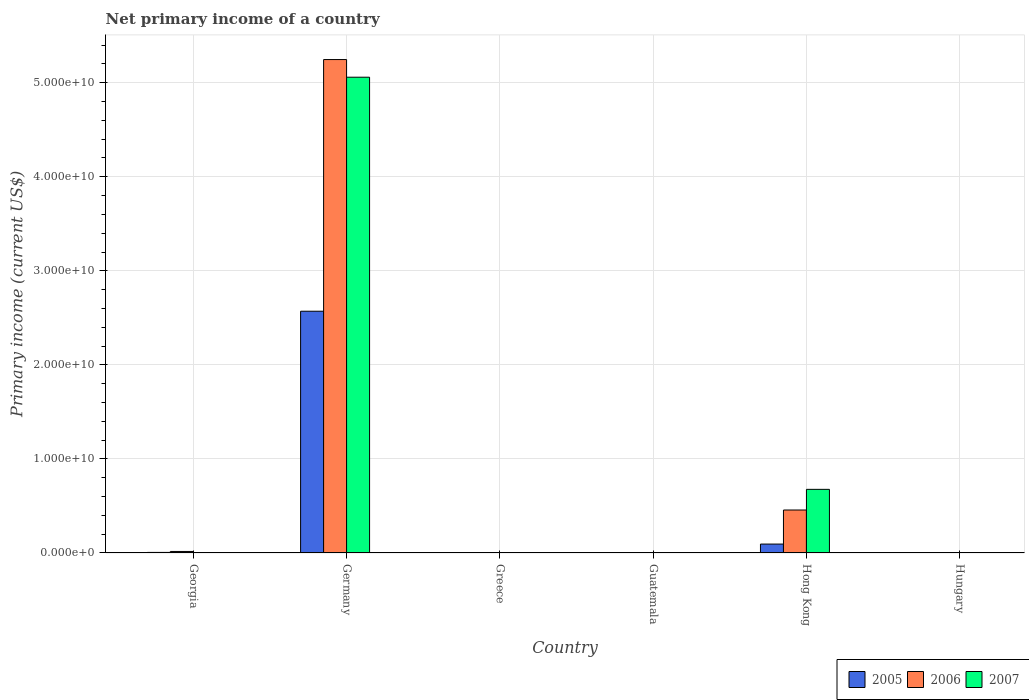How many different coloured bars are there?
Offer a very short reply. 3. Are the number of bars on each tick of the X-axis equal?
Provide a succinct answer. No. What is the label of the 4th group of bars from the left?
Your answer should be compact. Guatemala. What is the primary income in 2005 in Hungary?
Offer a very short reply. 0. Across all countries, what is the maximum primary income in 2005?
Ensure brevity in your answer.  2.57e+1. Across all countries, what is the minimum primary income in 2006?
Your answer should be very brief. 0. In which country was the primary income in 2005 maximum?
Ensure brevity in your answer.  Germany. What is the total primary income in 2005 in the graph?
Your answer should be compact. 2.67e+1. What is the difference between the primary income in 2005 in Germany and that in Hong Kong?
Make the answer very short. 2.48e+1. What is the difference between the primary income in 2007 in Germany and the primary income in 2006 in Georgia?
Your answer should be compact. 5.04e+1. What is the average primary income in 2006 per country?
Keep it short and to the point. 9.53e+09. What is the difference between the primary income of/in 2007 and primary income of/in 2006 in Hong Kong?
Your response must be concise. 2.20e+09. What is the ratio of the primary income in 2006 in Germany to that in Hong Kong?
Offer a terse response. 11.48. Is the difference between the primary income in 2007 in Georgia and Germany greater than the difference between the primary income in 2006 in Georgia and Germany?
Give a very brief answer. Yes. What is the difference between the highest and the second highest primary income in 2007?
Your response must be concise. -6.73e+09. What is the difference between the highest and the lowest primary income in 2006?
Keep it short and to the point. 5.25e+1. In how many countries, is the primary income in 2006 greater than the average primary income in 2006 taken over all countries?
Keep it short and to the point. 1. Is it the case that in every country, the sum of the primary income in 2007 and primary income in 2005 is greater than the primary income in 2006?
Your response must be concise. No. How many bars are there?
Offer a very short reply. 9. Are all the bars in the graph horizontal?
Give a very brief answer. No. How many countries are there in the graph?
Provide a short and direct response. 6. What is the difference between two consecutive major ticks on the Y-axis?
Offer a very short reply. 1.00e+1. Are the values on the major ticks of Y-axis written in scientific E-notation?
Give a very brief answer. Yes. Does the graph contain any zero values?
Make the answer very short. Yes. Where does the legend appear in the graph?
Ensure brevity in your answer.  Bottom right. How are the legend labels stacked?
Offer a terse response. Horizontal. What is the title of the graph?
Provide a short and direct response. Net primary income of a country. Does "1994" appear as one of the legend labels in the graph?
Provide a succinct answer. No. What is the label or title of the X-axis?
Your answer should be compact. Country. What is the label or title of the Y-axis?
Provide a short and direct response. Primary income (current US$). What is the Primary income (current US$) of 2005 in Georgia?
Give a very brief answer. 6.16e+07. What is the Primary income (current US$) in 2006 in Georgia?
Provide a short and direct response. 1.62e+08. What is the Primary income (current US$) of 2007 in Georgia?
Your answer should be very brief. 3.68e+07. What is the Primary income (current US$) in 2005 in Germany?
Keep it short and to the point. 2.57e+1. What is the Primary income (current US$) of 2006 in Germany?
Provide a short and direct response. 5.25e+1. What is the Primary income (current US$) of 2007 in Germany?
Offer a terse response. 5.06e+1. What is the Primary income (current US$) of 2005 in Greece?
Offer a terse response. 0. What is the Primary income (current US$) in 2007 in Greece?
Make the answer very short. 0. What is the Primary income (current US$) of 2005 in Guatemala?
Provide a short and direct response. 0. What is the Primary income (current US$) of 2006 in Guatemala?
Ensure brevity in your answer.  0. What is the Primary income (current US$) of 2005 in Hong Kong?
Offer a terse response. 9.49e+08. What is the Primary income (current US$) in 2006 in Hong Kong?
Your answer should be compact. 4.57e+09. What is the Primary income (current US$) of 2007 in Hong Kong?
Offer a terse response. 6.77e+09. What is the Primary income (current US$) of 2005 in Hungary?
Your answer should be compact. 0. What is the Primary income (current US$) of 2007 in Hungary?
Your answer should be very brief. 0. Across all countries, what is the maximum Primary income (current US$) of 2005?
Offer a very short reply. 2.57e+1. Across all countries, what is the maximum Primary income (current US$) of 2006?
Provide a succinct answer. 5.25e+1. Across all countries, what is the maximum Primary income (current US$) of 2007?
Keep it short and to the point. 5.06e+1. Across all countries, what is the minimum Primary income (current US$) in 2005?
Your answer should be very brief. 0. Across all countries, what is the minimum Primary income (current US$) of 2007?
Keep it short and to the point. 0. What is the total Primary income (current US$) of 2005 in the graph?
Your response must be concise. 2.67e+1. What is the total Primary income (current US$) of 2006 in the graph?
Your answer should be compact. 5.72e+1. What is the total Primary income (current US$) of 2007 in the graph?
Keep it short and to the point. 5.74e+1. What is the difference between the Primary income (current US$) in 2005 in Georgia and that in Germany?
Keep it short and to the point. -2.56e+1. What is the difference between the Primary income (current US$) of 2006 in Georgia and that in Germany?
Your response must be concise. -5.23e+1. What is the difference between the Primary income (current US$) in 2007 in Georgia and that in Germany?
Your response must be concise. -5.06e+1. What is the difference between the Primary income (current US$) of 2005 in Georgia and that in Hong Kong?
Your answer should be very brief. -8.88e+08. What is the difference between the Primary income (current US$) in 2006 in Georgia and that in Hong Kong?
Provide a short and direct response. -4.41e+09. What is the difference between the Primary income (current US$) of 2007 in Georgia and that in Hong Kong?
Offer a terse response. -6.73e+09. What is the difference between the Primary income (current US$) of 2005 in Germany and that in Hong Kong?
Offer a terse response. 2.48e+1. What is the difference between the Primary income (current US$) of 2006 in Germany and that in Hong Kong?
Keep it short and to the point. 4.79e+1. What is the difference between the Primary income (current US$) of 2007 in Germany and that in Hong Kong?
Offer a terse response. 4.38e+1. What is the difference between the Primary income (current US$) in 2005 in Georgia and the Primary income (current US$) in 2006 in Germany?
Ensure brevity in your answer.  -5.24e+1. What is the difference between the Primary income (current US$) in 2005 in Georgia and the Primary income (current US$) in 2007 in Germany?
Your answer should be compact. -5.05e+1. What is the difference between the Primary income (current US$) of 2006 in Georgia and the Primary income (current US$) of 2007 in Germany?
Provide a short and direct response. -5.04e+1. What is the difference between the Primary income (current US$) in 2005 in Georgia and the Primary income (current US$) in 2006 in Hong Kong?
Give a very brief answer. -4.51e+09. What is the difference between the Primary income (current US$) of 2005 in Georgia and the Primary income (current US$) of 2007 in Hong Kong?
Make the answer very short. -6.70e+09. What is the difference between the Primary income (current US$) in 2006 in Georgia and the Primary income (current US$) in 2007 in Hong Kong?
Your answer should be very brief. -6.60e+09. What is the difference between the Primary income (current US$) of 2005 in Germany and the Primary income (current US$) of 2006 in Hong Kong?
Offer a terse response. 2.11e+1. What is the difference between the Primary income (current US$) in 2005 in Germany and the Primary income (current US$) in 2007 in Hong Kong?
Provide a short and direct response. 1.89e+1. What is the difference between the Primary income (current US$) of 2006 in Germany and the Primary income (current US$) of 2007 in Hong Kong?
Offer a very short reply. 4.57e+1. What is the average Primary income (current US$) in 2005 per country?
Keep it short and to the point. 4.45e+09. What is the average Primary income (current US$) in 2006 per country?
Offer a very short reply. 9.53e+09. What is the average Primary income (current US$) in 2007 per country?
Provide a succinct answer. 9.57e+09. What is the difference between the Primary income (current US$) in 2005 and Primary income (current US$) in 2006 in Georgia?
Offer a very short reply. -1.01e+08. What is the difference between the Primary income (current US$) of 2005 and Primary income (current US$) of 2007 in Georgia?
Make the answer very short. 2.47e+07. What is the difference between the Primary income (current US$) of 2006 and Primary income (current US$) of 2007 in Georgia?
Make the answer very short. 1.25e+08. What is the difference between the Primary income (current US$) in 2005 and Primary income (current US$) in 2006 in Germany?
Give a very brief answer. -2.68e+1. What is the difference between the Primary income (current US$) in 2005 and Primary income (current US$) in 2007 in Germany?
Your answer should be very brief. -2.49e+1. What is the difference between the Primary income (current US$) in 2006 and Primary income (current US$) in 2007 in Germany?
Ensure brevity in your answer.  1.88e+09. What is the difference between the Primary income (current US$) in 2005 and Primary income (current US$) in 2006 in Hong Kong?
Keep it short and to the point. -3.62e+09. What is the difference between the Primary income (current US$) of 2005 and Primary income (current US$) of 2007 in Hong Kong?
Ensure brevity in your answer.  -5.82e+09. What is the difference between the Primary income (current US$) of 2006 and Primary income (current US$) of 2007 in Hong Kong?
Offer a very short reply. -2.20e+09. What is the ratio of the Primary income (current US$) of 2005 in Georgia to that in Germany?
Offer a very short reply. 0. What is the ratio of the Primary income (current US$) in 2006 in Georgia to that in Germany?
Provide a short and direct response. 0. What is the ratio of the Primary income (current US$) in 2007 in Georgia to that in Germany?
Keep it short and to the point. 0. What is the ratio of the Primary income (current US$) in 2005 in Georgia to that in Hong Kong?
Keep it short and to the point. 0.06. What is the ratio of the Primary income (current US$) in 2006 in Georgia to that in Hong Kong?
Keep it short and to the point. 0.04. What is the ratio of the Primary income (current US$) in 2007 in Georgia to that in Hong Kong?
Offer a terse response. 0.01. What is the ratio of the Primary income (current US$) in 2005 in Germany to that in Hong Kong?
Your response must be concise. 27.09. What is the ratio of the Primary income (current US$) of 2006 in Germany to that in Hong Kong?
Keep it short and to the point. 11.48. What is the ratio of the Primary income (current US$) in 2007 in Germany to that in Hong Kong?
Give a very brief answer. 7.48. What is the difference between the highest and the second highest Primary income (current US$) in 2005?
Your response must be concise. 2.48e+1. What is the difference between the highest and the second highest Primary income (current US$) of 2006?
Ensure brevity in your answer.  4.79e+1. What is the difference between the highest and the second highest Primary income (current US$) of 2007?
Make the answer very short. 4.38e+1. What is the difference between the highest and the lowest Primary income (current US$) of 2005?
Give a very brief answer. 2.57e+1. What is the difference between the highest and the lowest Primary income (current US$) of 2006?
Give a very brief answer. 5.25e+1. What is the difference between the highest and the lowest Primary income (current US$) of 2007?
Your answer should be compact. 5.06e+1. 